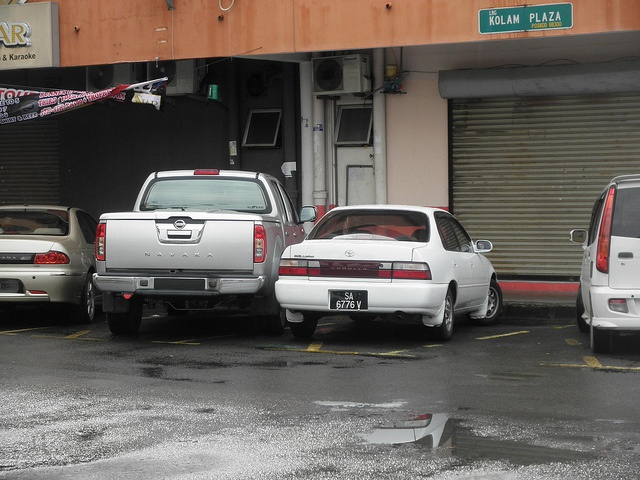Describe the objects in this image and their specific colors. I can see truck in olive, darkgray, black, lightgray, and gray tones, car in olive, lightgray, black, darkgray, and gray tones, car in olive, gray, lightgray, darkgray, and black tones, and car in olive, black, gray, lightgray, and darkgray tones in this image. 